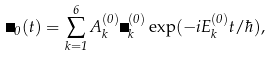Convert formula to latex. <formula><loc_0><loc_0><loc_500><loc_500>\Psi _ { 0 } ( t ) = \sum _ { k = 1 } ^ { 6 } A _ { k } ^ { ( 0 ) } \Psi _ { k } ^ { ( 0 ) } \exp ( - i E _ { k } ^ { ( 0 ) } t / \hbar { ) } ,</formula> 